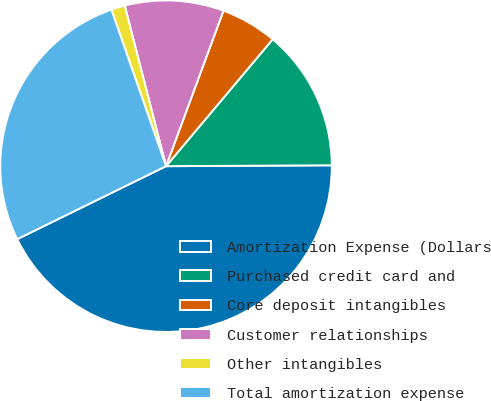<chart> <loc_0><loc_0><loc_500><loc_500><pie_chart><fcel>Amortization Expense (Dollars<fcel>Purchased credit card and<fcel>Core deposit intangibles<fcel>Customer relationships<fcel>Other intangibles<fcel>Total amortization expense<nl><fcel>42.83%<fcel>13.79%<fcel>5.49%<fcel>9.64%<fcel>1.34%<fcel>26.91%<nl></chart> 